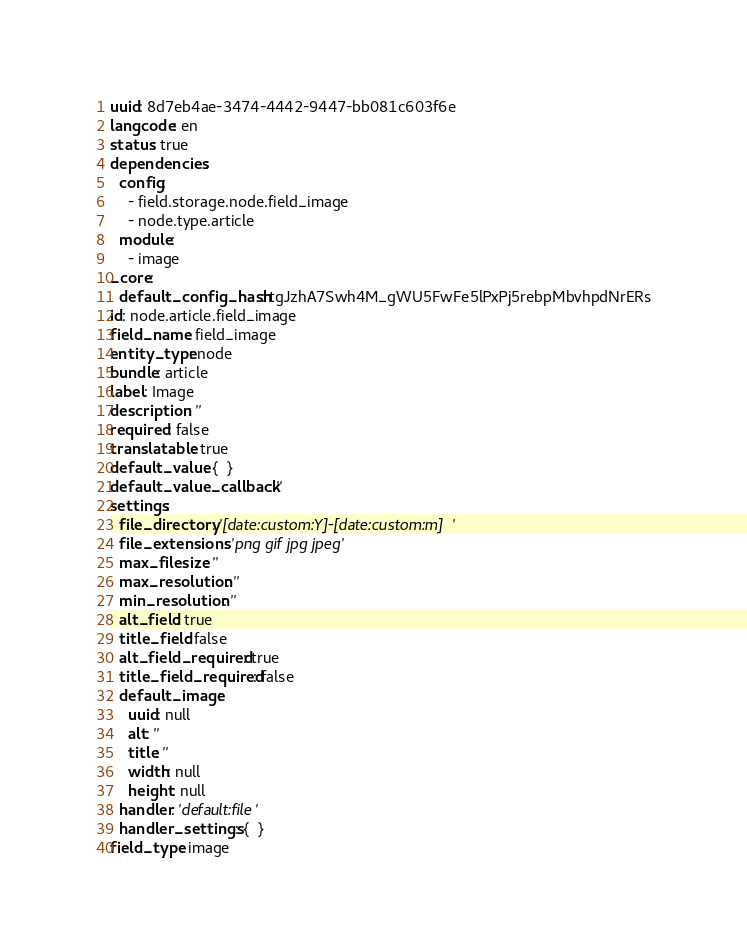Convert code to text. <code><loc_0><loc_0><loc_500><loc_500><_YAML_>uuid: 8d7eb4ae-3474-4442-9447-bb081c603f6e
langcode: en
status: true
dependencies:
  config:
    - field.storage.node.field_image
    - node.type.article
  module:
    - image
_core:
  default_config_hash: tgJzhA7Swh4M_gWU5FwFe5lPxPj5rebpMbvhpdNrERs
id: node.article.field_image
field_name: field_image
entity_type: node
bundle: article
label: Image
description: ''
required: false
translatable: true
default_value: {  }
default_value_callback: ''
settings:
  file_directory: '[date:custom:Y]-[date:custom:m]'
  file_extensions: 'png gif jpg jpeg'
  max_filesize: ''
  max_resolution: ''
  min_resolution: ''
  alt_field: true
  title_field: false
  alt_field_required: true
  title_field_required: false
  default_image:
    uuid: null
    alt: ''
    title: ''
    width: null
    height: null
  handler: 'default:file'
  handler_settings: {  }
field_type: image
</code> 